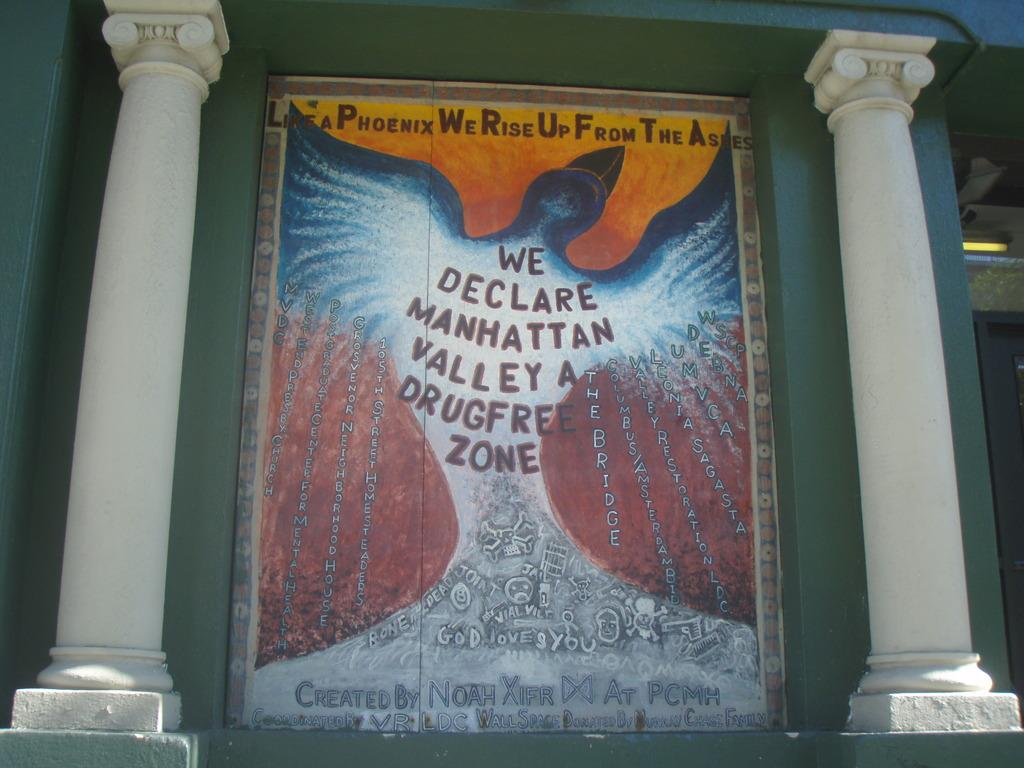<image>
Present a compact description of the photo's key features. A wall mural declaring that manhattan valley is free of drugs. 